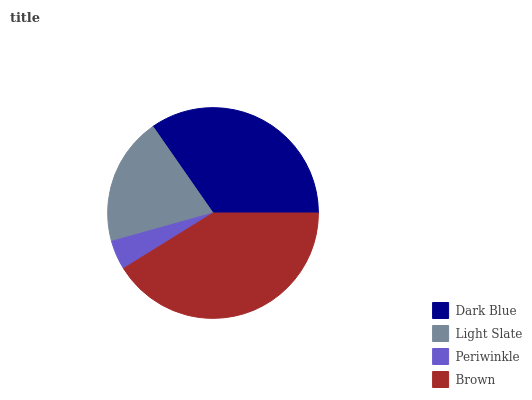Is Periwinkle the minimum?
Answer yes or no. Yes. Is Brown the maximum?
Answer yes or no. Yes. Is Light Slate the minimum?
Answer yes or no. No. Is Light Slate the maximum?
Answer yes or no. No. Is Dark Blue greater than Light Slate?
Answer yes or no. Yes. Is Light Slate less than Dark Blue?
Answer yes or no. Yes. Is Light Slate greater than Dark Blue?
Answer yes or no. No. Is Dark Blue less than Light Slate?
Answer yes or no. No. Is Dark Blue the high median?
Answer yes or no. Yes. Is Light Slate the low median?
Answer yes or no. Yes. Is Light Slate the high median?
Answer yes or no. No. Is Periwinkle the low median?
Answer yes or no. No. 